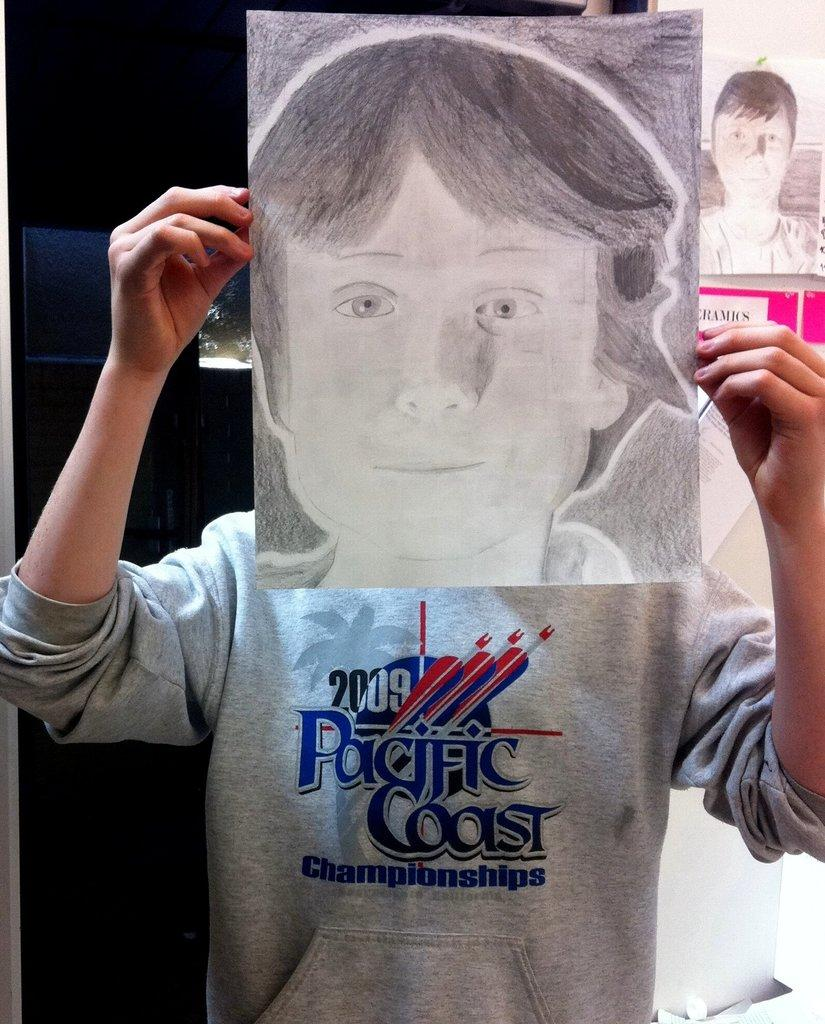What is the main subject of the image? There is a person standing in the image. What can be observed about the person's attire? The person is wearing clothes. How was the image created? The image is a pencil sketch on paper. What type of prison can be seen in the background of the image? There is no prison present in the image; it features a person standing in a pencil sketch on paper. How many letters are visible in the image? There are no letters visible in the image, as it is a pencil sketch of a person standing. 